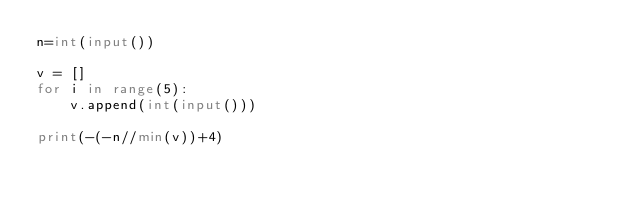Convert code to text. <code><loc_0><loc_0><loc_500><loc_500><_Python_>n=int(input())

v = []
for i in range(5):
    v.append(int(input()))

print(-(-n//min(v))+4)</code> 